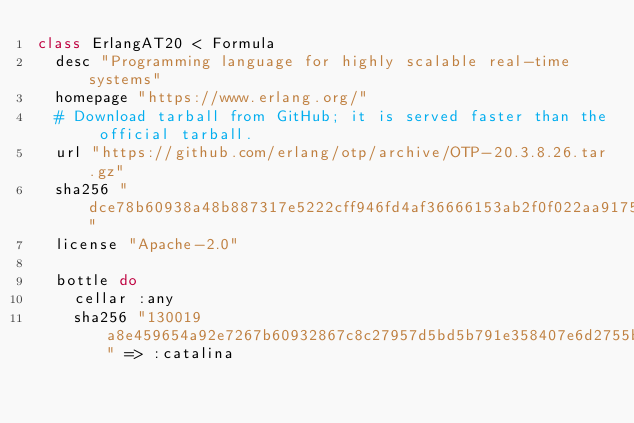<code> <loc_0><loc_0><loc_500><loc_500><_Ruby_>class ErlangAT20 < Formula
  desc "Programming language for highly scalable real-time systems"
  homepage "https://www.erlang.org/"
  # Download tarball from GitHub; it is served faster than the official tarball.
  url "https://github.com/erlang/otp/archive/OTP-20.3.8.26.tar.gz"
  sha256 "dce78b60938a48b887317e5222cff946fd4af36666153ab2f0f022aa91755813"
  license "Apache-2.0"

  bottle do
    cellar :any
    sha256 "130019a8e459654a92e7267b60932867c8c27957d5bd5b791e358407e6d2755b" => :catalina</code> 